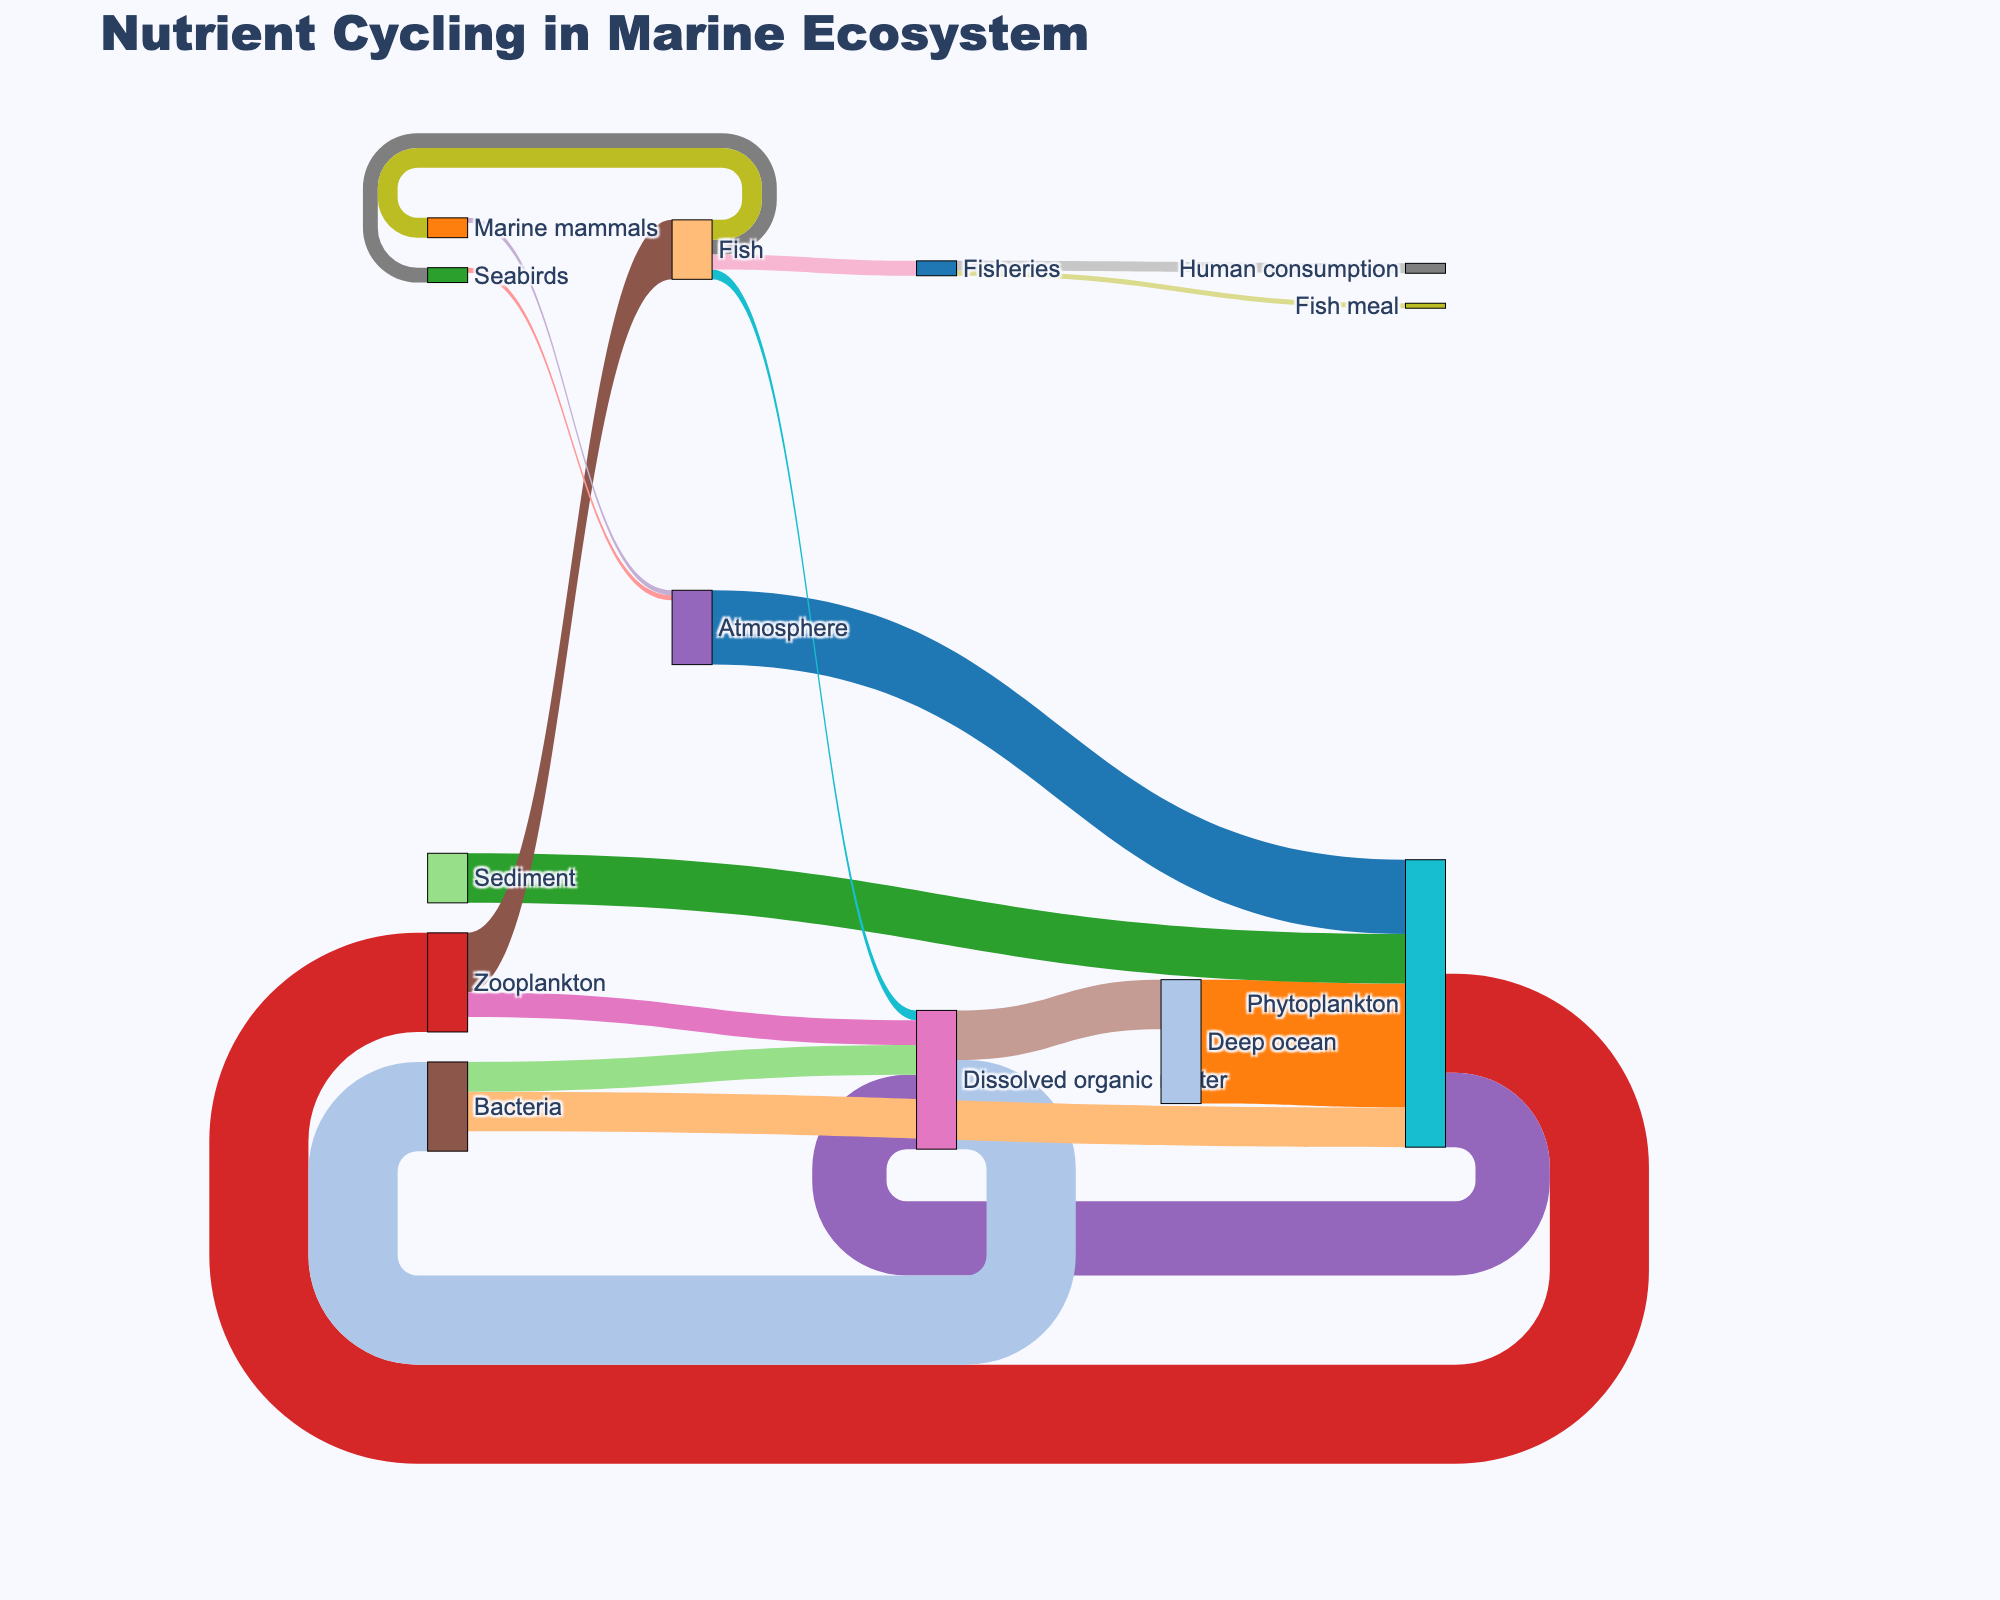What is the title of the Sankey diagram? The title is written at the top center of the diagram. It should be clearly visible as a textual element.
Answer: Nutrient Cycling in Marine Ecosystem How many different nodes are there in the diagram? Nodes represent the distinct elements involved in the nutrient cycling process and are labeled in the diagram. By counting them, we determine there are 17 nodes.
Answer: 17 Which node receives the highest amount of nutrients from other sources? The flow values into each node indicate received nutrients. By summing the values directed to each node, 'Phytoplankton' receives (15+25+10) = 50 units, which is the highest.
Answer: Phytoplankton What is the total nutrient flow from 'Fish' to other nodes? The flow from 'Fish' is distributed to 'Seabirds' (3), 'Marine mammals' (4), 'Dissolved organic matter' (2), and 'Fisheries' (3). Summing these gives 3+4+2+3 = 12 units.
Answer: 12 units Which nodes receive nutrients from 'Zooplankton' and what's the total flow? 'Zooplankton' flows to 'Fish' (12) and 'Dissolved organic matter' (5). Adding them gives 12+5 = 17 units.
Answer: Fish and Dissolved organic matter; 17 units Compare the nutrient flow from 'Atmosphere' to 'Phytoplankton' and 'Seabirds' to 'Atmosphere'. Which is larger and by how much? The flow from 'Atmosphere' to 'Phytoplankton' is 15 units, whereas from 'Seabirds' to 'Atmosphere' is 1 unit. The difference is 15 - 1 = 14 units.
Answer: Atmosphere to Phytoplankton is larger by 14 units What is the combined nutrient flow into 'Dissolved organic matter'? Summing the values directed to 'Dissolved organic matter' from 'Phytoplankton' (15), 'Zooplankton' (5), 'Fish' (2), and 'Bacteria' (6), the total is 15+5+2+6 = 28 units.
Answer: 28 units Which node transfers nutrients to both 'Phytoplankton' and 'Dissolved organic matter'? The diagram shows 'Bacteria' connecting to both 'Phytoplankton' and 'Dissolved organic matter'. This can be observed directly.
Answer: Bacteria What is the nutrient flow from 'Phytoplankton' to 'Zooplankton' relative to its outflow to other nodes? 'Phytoplankton' flows to 'Zooplankton' (20), 'Dissolved organic matter' (15). The total outflow is 20+15 = 35. The flow to 'Zooplankton' is 20/35 = 57.14%.
Answer: 57.14% How much nutrient flow goes from 'Dissolved organic matter' back to 'Deep ocean'? The diagram directly shows nutrient flow from 'Dissolved organic matter' to 'Deep ocean' as 10 units. This can be read from the flow labels.
Answer: 10 units 